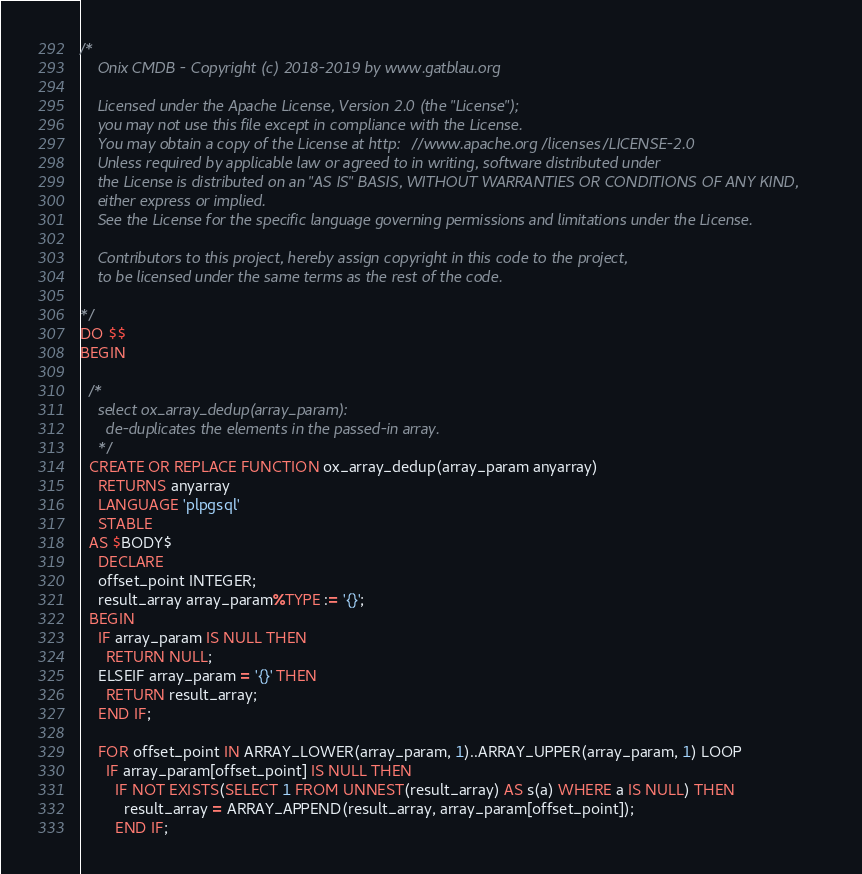Convert code to text. <code><loc_0><loc_0><loc_500><loc_500><_SQL_>/*
    Onix CMDB - Copyright (c) 2018-2019 by www.gatblau.org

    Licensed under the Apache License, Version 2.0 (the "License");
    you may not use this file except in compliance with the License.
    You may obtain a copy of the License at http://www.apache.org/licenses/LICENSE-2.0
    Unless required by applicable law or agreed to in writing, software distributed under
    the License is distributed on an "AS IS" BASIS, WITHOUT WARRANTIES OR CONDITIONS OF ANY KIND,
    either express or implied.
    See the License for the specific language governing permissions and limitations under the License.

    Contributors to this project, hereby assign copyright in this code to the project,
    to be licensed under the same terms as the rest of the code.

*/
DO $$
BEGIN

  /*
    select ox_array_dedup(array_param):
      de-duplicates the elements in the passed-in array.
    */
  CREATE OR REPLACE FUNCTION ox_array_dedup(array_param anyarray)
    RETURNS anyarray
    LANGUAGE 'plpgsql'
    STABLE
  AS $BODY$
    DECLARE
    offset_point INTEGER;
    result_array array_param%TYPE := '{}';
  BEGIN
    IF array_param IS NULL THEN
      RETURN NULL;
    ELSEIF array_param = '{}' THEN
      RETURN result_array;
    END IF;

    FOR offset_point IN ARRAY_LOWER(array_param, 1)..ARRAY_UPPER(array_param, 1) LOOP
      IF array_param[offset_point] IS NULL THEN
        IF NOT EXISTS(SELECT 1 FROM UNNEST(result_array) AS s(a) WHERE a IS NULL) THEN
          result_array = ARRAY_APPEND(result_array, array_param[offset_point]);
        END IF;</code> 